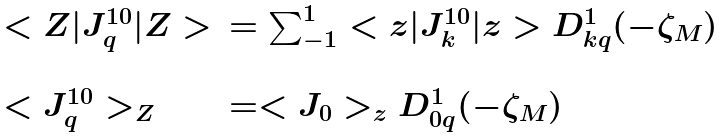<formula> <loc_0><loc_0><loc_500><loc_500>\begin{array} { l l } < Z | J ^ { 1 0 } _ { q } | Z > & = \sum ^ { 1 } _ { - 1 } < z | J ^ { 1 0 } _ { k } | z > D ^ { 1 } _ { k q } ( - \zeta _ { M } ) \\ & \\ < J ^ { 1 0 } _ { q } > _ { Z } & = < J _ { 0 } > _ { z } D ^ { 1 } _ { 0 q } ( - \zeta _ { M } ) \end{array}</formula> 